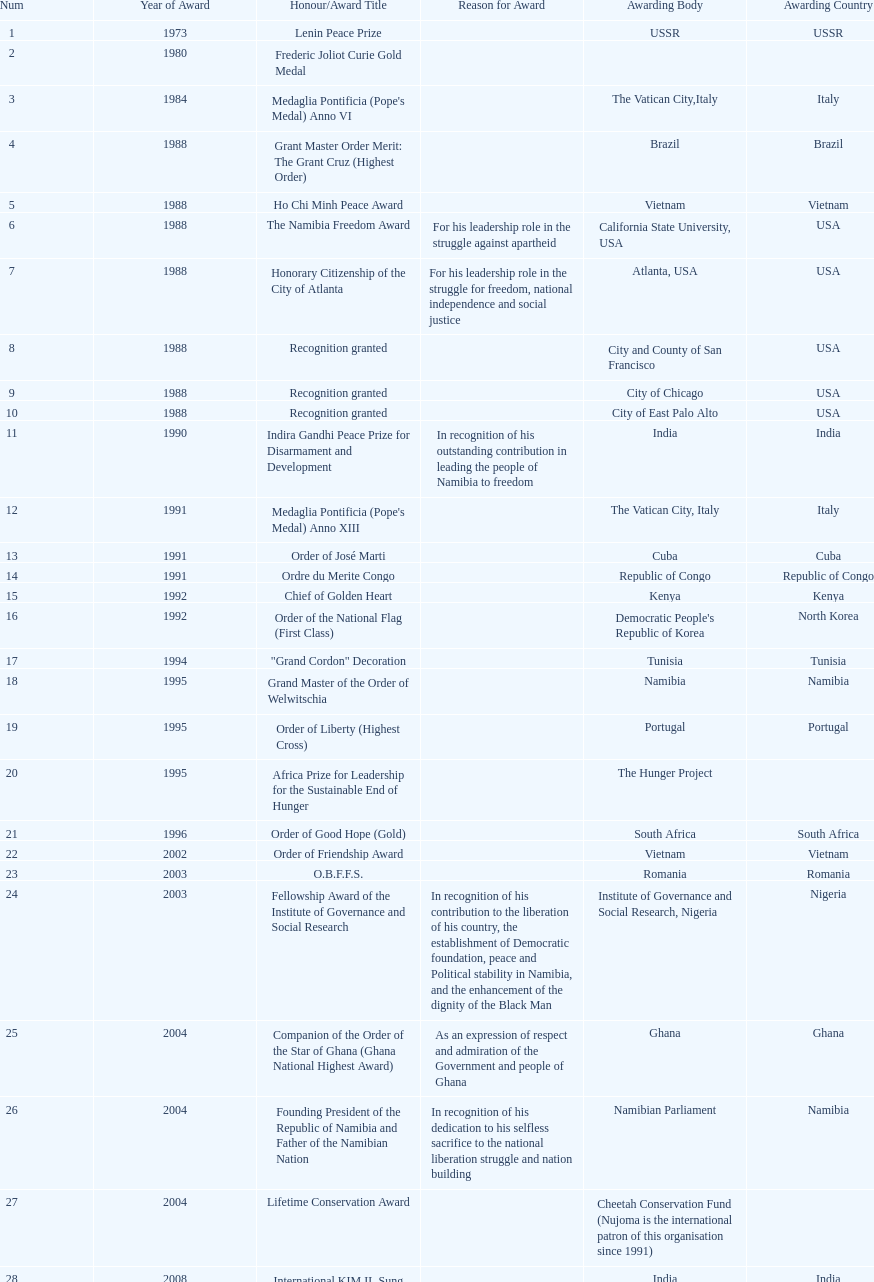What was the last award that nujoma won? Sir Seretse Khama SADC Meda. 